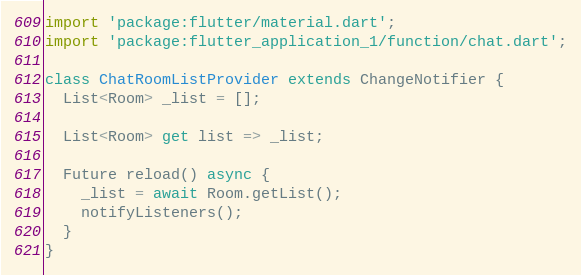Convert code to text. <code><loc_0><loc_0><loc_500><loc_500><_Dart_>import 'package:flutter/material.dart';
import 'package:flutter_application_1/function/chat.dart';

class ChatRoomListProvider extends ChangeNotifier {
  List<Room> _list = [];

  List<Room> get list => _list;

  Future reload() async {
    _list = await Room.getList();
    notifyListeners();
  }
}
</code> 